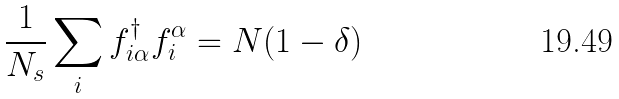Convert formula to latex. <formula><loc_0><loc_0><loc_500><loc_500>\frac { 1 } { N _ { s } } \sum _ { i } f _ { i \alpha } ^ { \dagger } f _ { i } ^ { \alpha } = N ( 1 - \delta )</formula> 